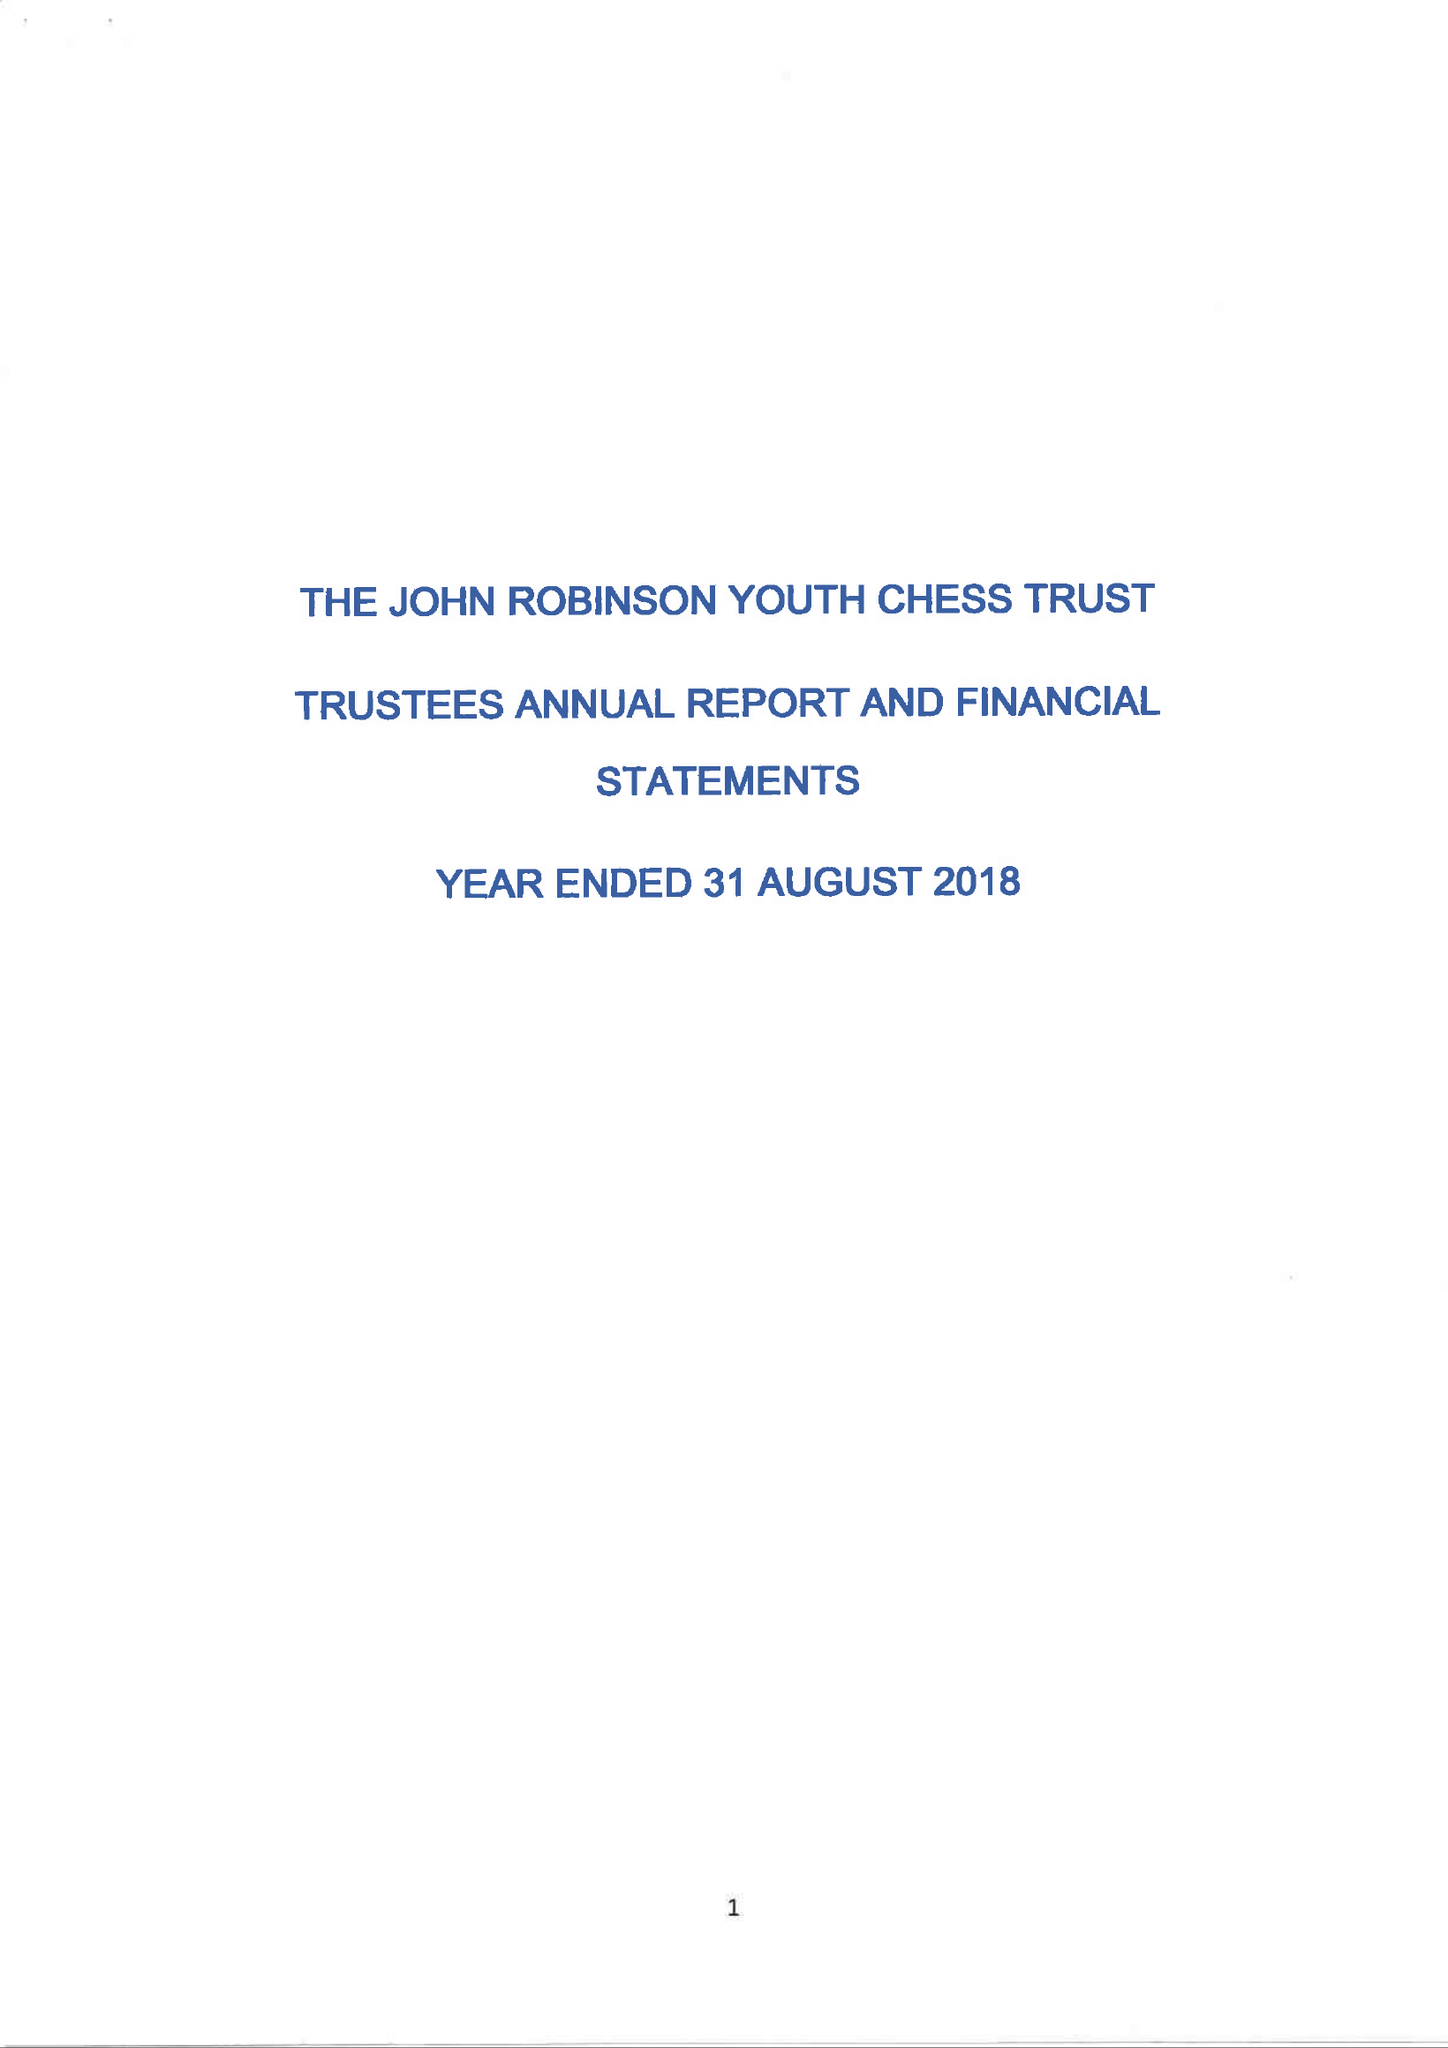What is the value for the charity_number?
Answer the question using a single word or phrase. 1116981 